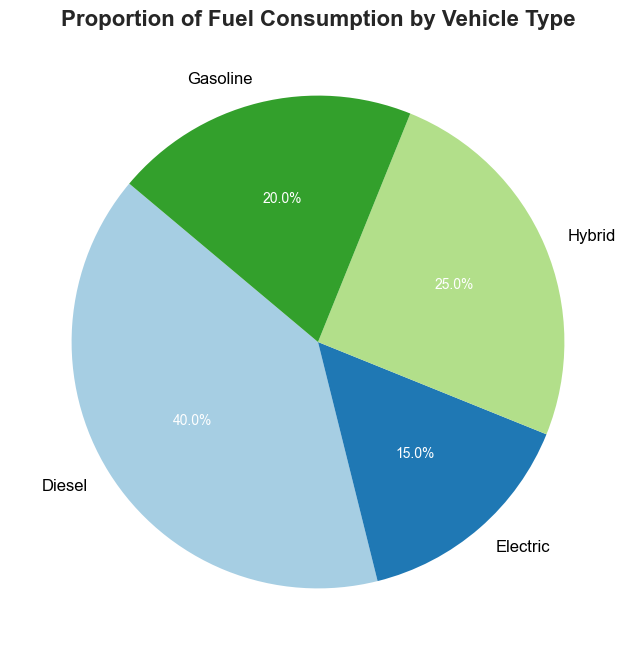Which vehicle type has the highest fuel consumption? The pie chart shows the proportion of fuel consumption by vehicle type. By looking at the size of the slices, we can see that Diesel has the largest slice, indicating the highest fuel consumption.
Answer: Diesel What's the total proportion of non-electric vehicles? To find the total proportion of non-electric vehicles, we need to sum the proportions of Diesel, Hybrid, and Gasoline: 40% (Diesel) + 25% (Hybrid) + 20% (Gasoline) = 85%.
Answer: 85% Which vehicle type consumes less fuel than Gasoline? By comparing the sizes of the slices, we can see that Electric (15%) consumes less fuel than Gasoline (20%).
Answer: Electric Is the fuel consumption of Hybrid vehicles more than half of Diesel vehicles? Diesel vehicles consume 40%, and Hybrid vehicles consume 25%. Half of Diesel's consumption is 20% (40% / 2). Since 25% is greater than 20%, Hybrid vehicles consume more than half of Diesel vehicles' consumption.
Answer: Yes What is the difference in fuel consumption between the highest and lowest vehicle types? The highest fuel consumption is Diesel at 40%, and the lowest is Electric at 15%. The difference is 40% - 15% = 25%.
Answer: 25% What's the proportion difference between Hybrid and Gasoline vehicles? The pie chart shows Hybrid with 25% and Gasoline with 20%. The difference is 25% - 20% = 5%.
Answer: 5% Among the vehicle types, which one has the second-largest fuel consumption proportion? Diesel has the highest proportion. Hybrid, with 25%, is the second largest as it has a larger pie slice compared to Gasoline and Electric.
Answer: Hybrid How many times greater is Diesel's consumption compared to Electric's? Diesel's consumption is 40% and Electric's is 15%. Dividing Diesel's consumption by Electric's gives us 40% / 15% = 2.67 times greater.
Answer: 2.67 times Which vehicle type has the smallest slice in the pie chart? The pie chart shows that Electric has the smallest slice representing 15% of fuel consumption.
Answer: Electric If Diesel and Gasoline consumption are combined, what proportion do they represent? Combine Diesel (40%) and Gasoline (20%) by summing their percentages: 40% + 20% = 60%.
Answer: 60% 